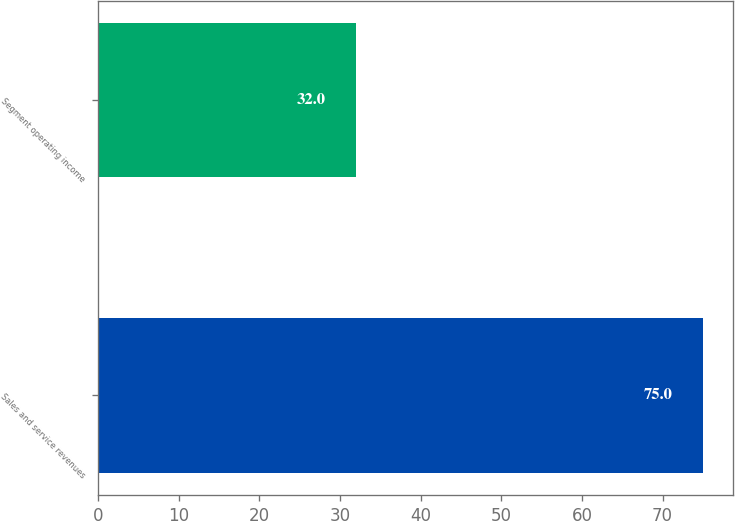Convert chart to OTSL. <chart><loc_0><loc_0><loc_500><loc_500><bar_chart><fcel>Sales and service revenues<fcel>Segment operating income<nl><fcel>75<fcel>32<nl></chart> 